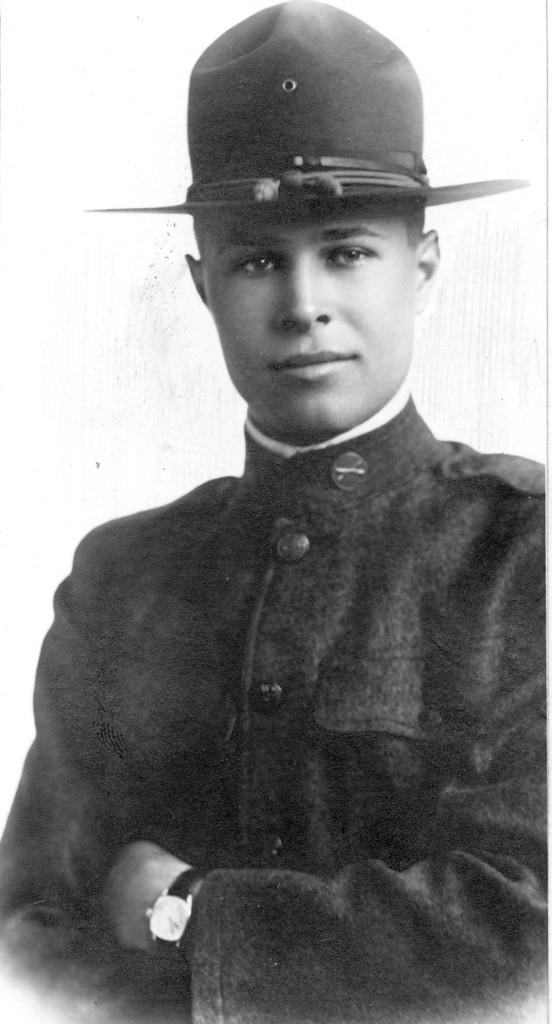What can be seen in the image? There is a person in the image. What is the person wearing? The person is wearing a uniform and a hat. What is the person's facial expression? The person is smiling. What is the color scheme of the image? The image is black and white. What type of detail can be seen on the person's uniform in the image? There is no specific detail mentioned on the person's uniform in the provided facts, so it cannot be determined from the image. 